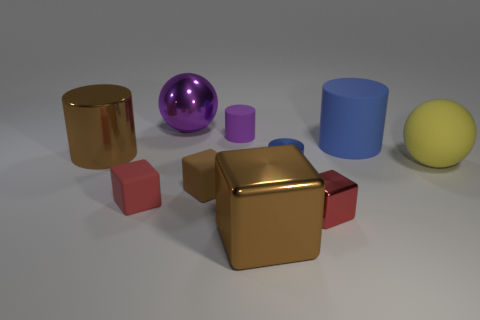What is the size of the cube that is in front of the red thing that is on the right side of the large brown thing in front of the big matte sphere?
Your answer should be compact. Large. There is a red cube that is made of the same material as the large purple object; what is its size?
Ensure brevity in your answer.  Small. There is a rubber object that is both on the right side of the purple rubber thing and behind the matte sphere; what is its color?
Keep it short and to the point. Blue. Is the shape of the large brown thing that is behind the big block the same as the metal thing behind the large blue rubber thing?
Offer a very short reply. No. What material is the large sphere that is left of the red metal object?
Make the answer very short. Metal. What size is the metal object that is the same color as the big shiny cylinder?
Offer a very short reply. Large. How many things are either red cubes that are to the right of the small brown rubber object or purple balls?
Make the answer very short. 2. Is the number of blue cylinders that are to the left of the large purple metallic sphere the same as the number of red cylinders?
Your answer should be compact. Yes. Does the brown rubber block have the same size as the yellow matte object?
Make the answer very short. No. What color is the rubber cylinder that is the same size as the red matte cube?
Offer a very short reply. Purple. 